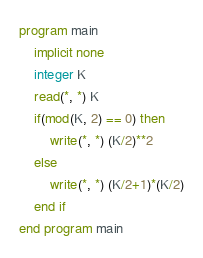Convert code to text. <code><loc_0><loc_0><loc_500><loc_500><_FORTRAN_>program main
	implicit none
	integer K
	read(*, *) K
	if(mod(K, 2) == 0) then
		write(*, *) (K/2)**2
	else
		write(*, *) (K/2+1)*(K/2)
	end if
end program main</code> 